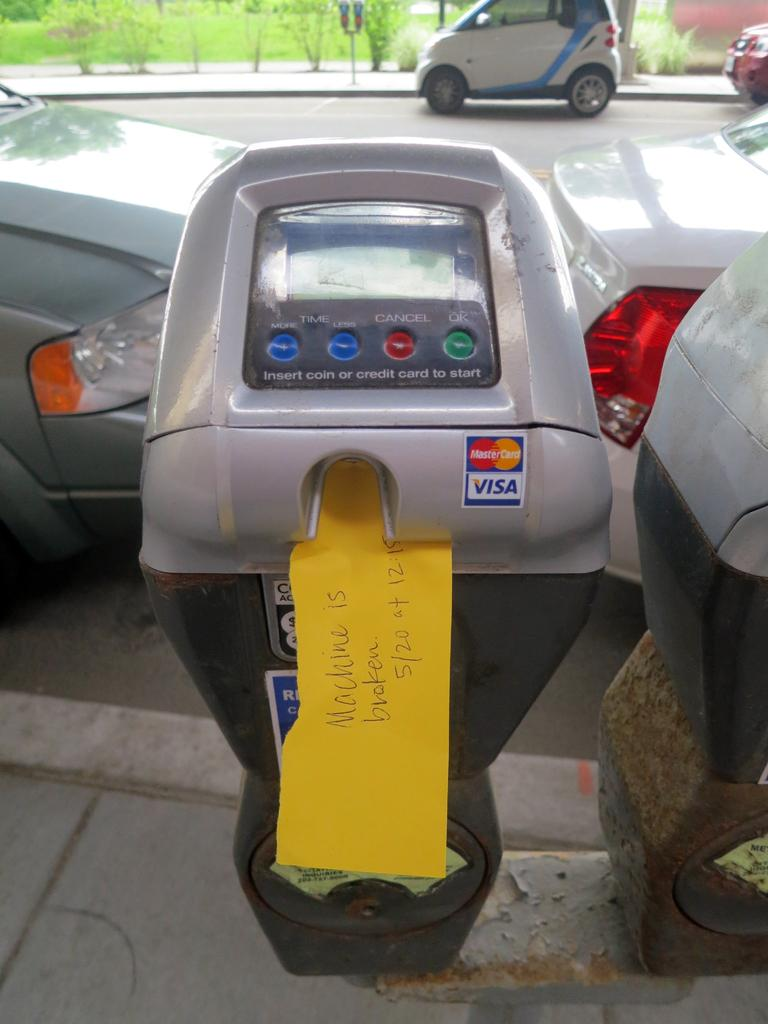Provide a one-sentence caption for the provided image. A parking meter that was not working on May 20. 